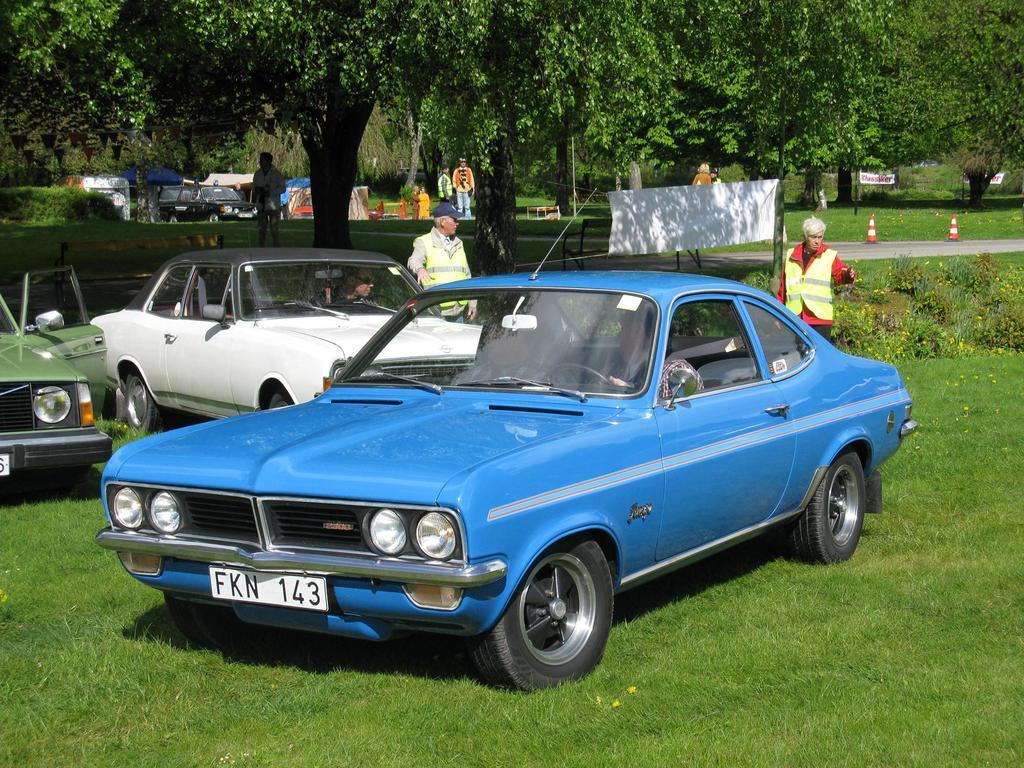What type of vehicles are on the grassy land in the image? There are cars on the grassy land in the image. What can be seen in the background of the image? In the background, there are people, traffic cones, grassy land, tents, a vehicle, and trees. How many vehicles are visible in the background? One vehicle is visible in the background. What type of cable is being used by the company in the image? There is no cable or company present in the image. Can you see any veins in the image? There are no veins visible in the image; it features cars on grassy land and various elements in the background. 